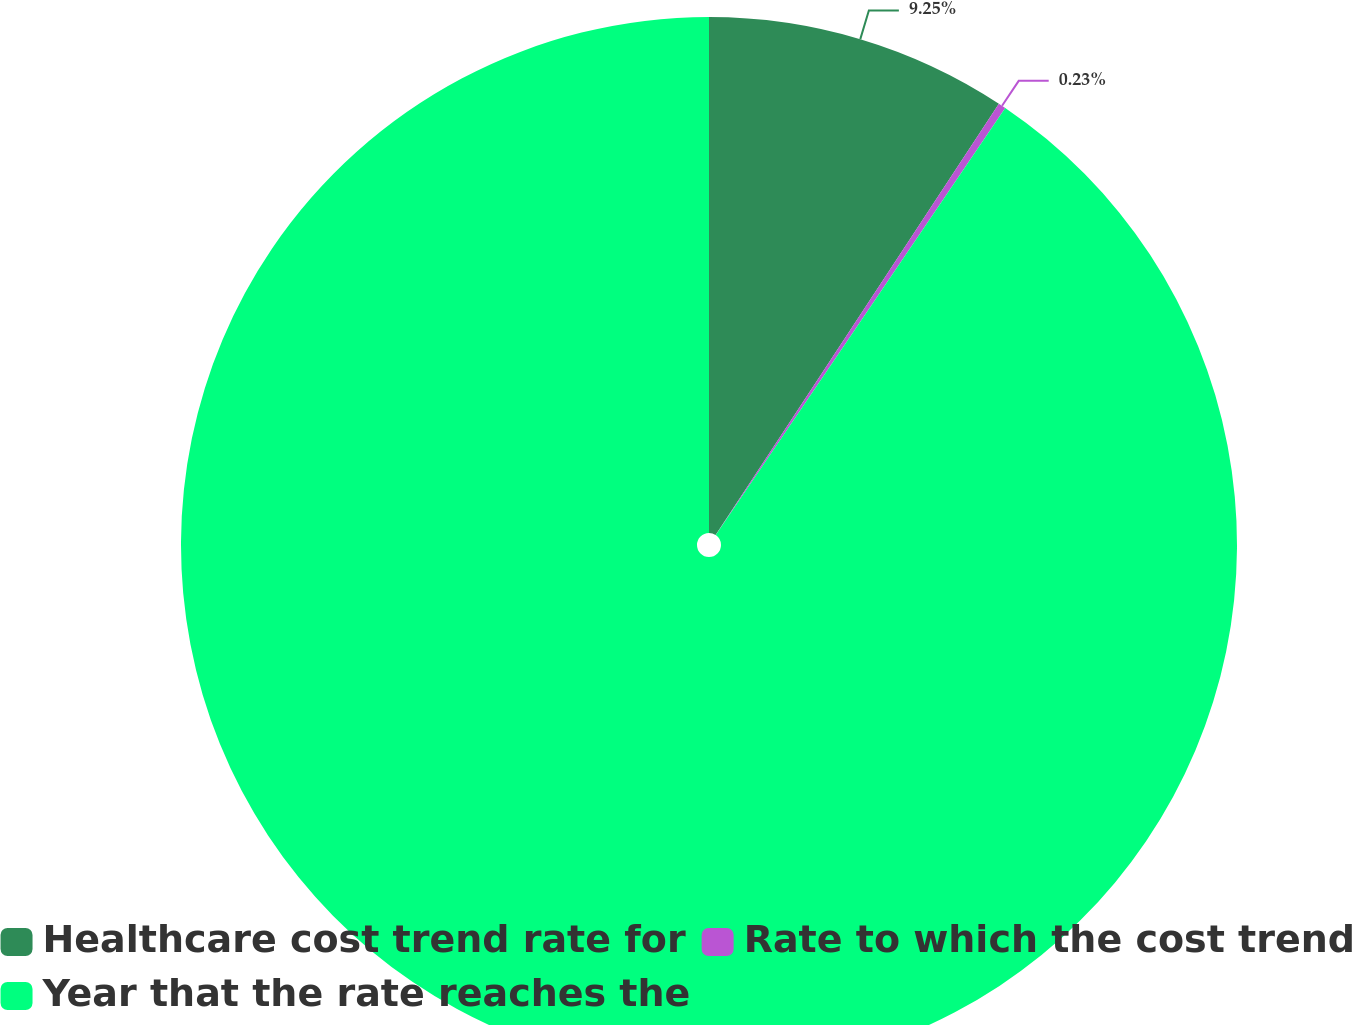<chart> <loc_0><loc_0><loc_500><loc_500><pie_chart><fcel>Healthcare cost trend rate for<fcel>Rate to which the cost trend<fcel>Year that the rate reaches the<nl><fcel>9.25%<fcel>0.23%<fcel>90.52%<nl></chart> 